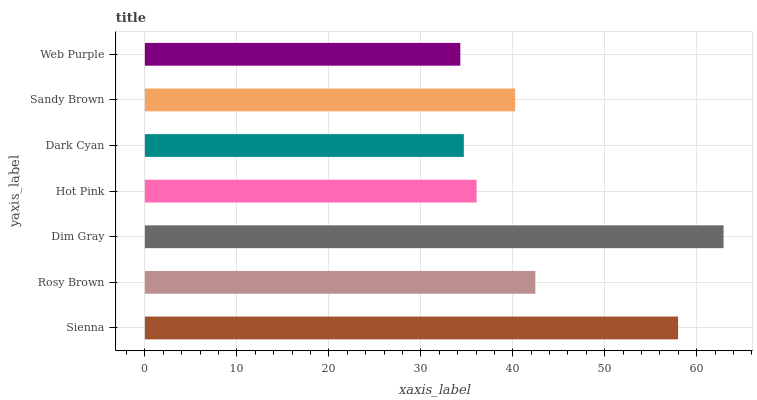Is Web Purple the minimum?
Answer yes or no. Yes. Is Dim Gray the maximum?
Answer yes or no. Yes. Is Rosy Brown the minimum?
Answer yes or no. No. Is Rosy Brown the maximum?
Answer yes or no. No. Is Sienna greater than Rosy Brown?
Answer yes or no. Yes. Is Rosy Brown less than Sienna?
Answer yes or no. Yes. Is Rosy Brown greater than Sienna?
Answer yes or no. No. Is Sienna less than Rosy Brown?
Answer yes or no. No. Is Sandy Brown the high median?
Answer yes or no. Yes. Is Sandy Brown the low median?
Answer yes or no. Yes. Is Hot Pink the high median?
Answer yes or no. No. Is Hot Pink the low median?
Answer yes or no. No. 